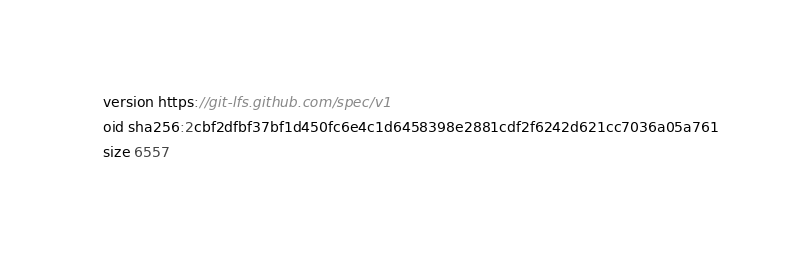<code> <loc_0><loc_0><loc_500><loc_500><_JavaScript_>version https://git-lfs.github.com/spec/v1
oid sha256:2cbf2dfbf37bf1d450fc6e4c1d6458398e2881cdf2f6242d621cc7036a05a761
size 6557
</code> 